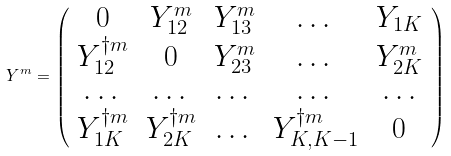Convert formula to latex. <formula><loc_0><loc_0><loc_500><loc_500>Y ^ { m } = \left ( \begin{array} { c c c c c } 0 & Y ^ { m } _ { 1 2 } & Y ^ { m } _ { 1 3 } & \dots & Y _ { 1 K } \\ Y ^ { \dagger m } _ { 1 2 } & 0 & Y ^ { m } _ { 2 3 } & \dots & Y ^ { m } _ { 2 K } \\ \dots & \dots & \dots & \dots & \dots \\ Y ^ { \dagger m } _ { 1 K } & Y ^ { \dagger m } _ { 2 K } & \dots & Y ^ { \dagger m } _ { K , K - 1 } & 0 \\ \end{array} \right )</formula> 